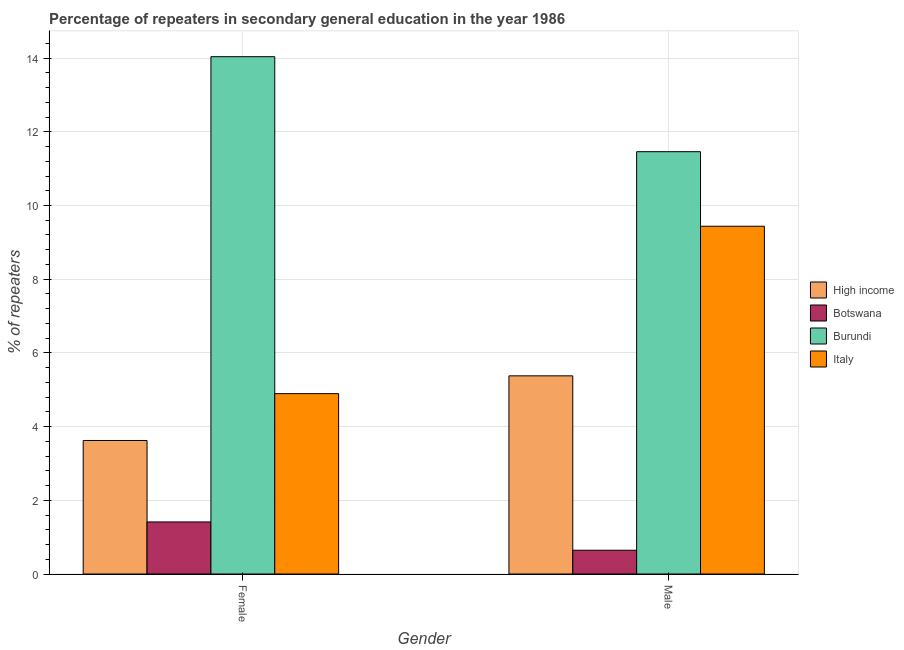Are the number of bars per tick equal to the number of legend labels?
Your response must be concise. Yes. Are the number of bars on each tick of the X-axis equal?
Provide a succinct answer. Yes. How many bars are there on the 2nd tick from the left?
Keep it short and to the point. 4. How many bars are there on the 1st tick from the right?
Offer a terse response. 4. What is the label of the 2nd group of bars from the left?
Your response must be concise. Male. What is the percentage of male repeaters in Italy?
Provide a short and direct response. 9.44. Across all countries, what is the maximum percentage of male repeaters?
Provide a succinct answer. 11.46. Across all countries, what is the minimum percentage of female repeaters?
Provide a succinct answer. 1.41. In which country was the percentage of male repeaters maximum?
Your answer should be very brief. Burundi. In which country was the percentage of male repeaters minimum?
Provide a short and direct response. Botswana. What is the total percentage of female repeaters in the graph?
Offer a terse response. 23.97. What is the difference between the percentage of male repeaters in Botswana and that in Burundi?
Your answer should be compact. -10.82. What is the difference between the percentage of male repeaters in High income and the percentage of female repeaters in Burundi?
Offer a very short reply. -8.66. What is the average percentage of male repeaters per country?
Your answer should be very brief. 6.73. What is the difference between the percentage of male repeaters and percentage of female repeaters in Botswana?
Make the answer very short. -0.77. What is the ratio of the percentage of female repeaters in Botswana to that in High income?
Your answer should be very brief. 0.39. Is the percentage of male repeaters in High income less than that in Burundi?
Provide a short and direct response. Yes. What does the 4th bar from the left in Female represents?
Your response must be concise. Italy. What does the 4th bar from the right in Male represents?
Give a very brief answer. High income. How many bars are there?
Ensure brevity in your answer.  8. Are all the bars in the graph horizontal?
Offer a very short reply. No. How many countries are there in the graph?
Keep it short and to the point. 4. Does the graph contain any zero values?
Give a very brief answer. No. How many legend labels are there?
Your answer should be very brief. 4. How are the legend labels stacked?
Your answer should be very brief. Vertical. What is the title of the graph?
Offer a terse response. Percentage of repeaters in secondary general education in the year 1986. Does "European Union" appear as one of the legend labels in the graph?
Offer a very short reply. No. What is the label or title of the Y-axis?
Ensure brevity in your answer.  % of repeaters. What is the % of repeaters of High income in Female?
Your answer should be very brief. 3.62. What is the % of repeaters of Botswana in Female?
Your answer should be very brief. 1.41. What is the % of repeaters of Burundi in Female?
Your answer should be very brief. 14.04. What is the % of repeaters of Italy in Female?
Provide a succinct answer. 4.89. What is the % of repeaters in High income in Male?
Your response must be concise. 5.38. What is the % of repeaters of Botswana in Male?
Offer a very short reply. 0.64. What is the % of repeaters of Burundi in Male?
Provide a short and direct response. 11.46. What is the % of repeaters in Italy in Male?
Give a very brief answer. 9.44. Across all Gender, what is the maximum % of repeaters in High income?
Ensure brevity in your answer.  5.38. Across all Gender, what is the maximum % of repeaters in Botswana?
Keep it short and to the point. 1.41. Across all Gender, what is the maximum % of repeaters in Burundi?
Your response must be concise. 14.04. Across all Gender, what is the maximum % of repeaters of Italy?
Provide a short and direct response. 9.44. Across all Gender, what is the minimum % of repeaters in High income?
Your answer should be very brief. 3.62. Across all Gender, what is the minimum % of repeaters of Botswana?
Your answer should be very brief. 0.64. Across all Gender, what is the minimum % of repeaters in Burundi?
Your answer should be very brief. 11.46. Across all Gender, what is the minimum % of repeaters in Italy?
Offer a terse response. 4.89. What is the total % of repeaters of High income in the graph?
Keep it short and to the point. 9. What is the total % of repeaters in Botswana in the graph?
Keep it short and to the point. 2.06. What is the total % of repeaters in Burundi in the graph?
Keep it short and to the point. 25.5. What is the total % of repeaters in Italy in the graph?
Give a very brief answer. 14.33. What is the difference between the % of repeaters of High income in Female and that in Male?
Offer a very short reply. -1.75. What is the difference between the % of repeaters in Botswana in Female and that in Male?
Make the answer very short. 0.77. What is the difference between the % of repeaters of Burundi in Female and that in Male?
Provide a succinct answer. 2.58. What is the difference between the % of repeaters of Italy in Female and that in Male?
Ensure brevity in your answer.  -4.54. What is the difference between the % of repeaters of High income in Female and the % of repeaters of Botswana in Male?
Offer a terse response. 2.98. What is the difference between the % of repeaters in High income in Female and the % of repeaters in Burundi in Male?
Provide a short and direct response. -7.84. What is the difference between the % of repeaters of High income in Female and the % of repeaters of Italy in Male?
Offer a very short reply. -5.81. What is the difference between the % of repeaters of Botswana in Female and the % of repeaters of Burundi in Male?
Your answer should be very brief. -10.05. What is the difference between the % of repeaters of Botswana in Female and the % of repeaters of Italy in Male?
Ensure brevity in your answer.  -8.02. What is the difference between the % of repeaters in Burundi in Female and the % of repeaters in Italy in Male?
Your answer should be compact. 4.6. What is the average % of repeaters of High income per Gender?
Offer a terse response. 4.5. What is the average % of repeaters of Botswana per Gender?
Make the answer very short. 1.03. What is the average % of repeaters in Burundi per Gender?
Ensure brevity in your answer.  12.75. What is the average % of repeaters in Italy per Gender?
Provide a succinct answer. 7.17. What is the difference between the % of repeaters in High income and % of repeaters in Botswana in Female?
Your answer should be compact. 2.21. What is the difference between the % of repeaters in High income and % of repeaters in Burundi in Female?
Ensure brevity in your answer.  -10.41. What is the difference between the % of repeaters of High income and % of repeaters of Italy in Female?
Ensure brevity in your answer.  -1.27. What is the difference between the % of repeaters in Botswana and % of repeaters in Burundi in Female?
Provide a succinct answer. -12.63. What is the difference between the % of repeaters in Botswana and % of repeaters in Italy in Female?
Offer a very short reply. -3.48. What is the difference between the % of repeaters in Burundi and % of repeaters in Italy in Female?
Your answer should be compact. 9.14. What is the difference between the % of repeaters of High income and % of repeaters of Botswana in Male?
Your answer should be compact. 4.73. What is the difference between the % of repeaters in High income and % of repeaters in Burundi in Male?
Offer a terse response. -6.08. What is the difference between the % of repeaters in High income and % of repeaters in Italy in Male?
Ensure brevity in your answer.  -4.06. What is the difference between the % of repeaters in Botswana and % of repeaters in Burundi in Male?
Your answer should be very brief. -10.81. What is the difference between the % of repeaters in Botswana and % of repeaters in Italy in Male?
Your response must be concise. -8.79. What is the difference between the % of repeaters in Burundi and % of repeaters in Italy in Male?
Offer a terse response. 2.02. What is the ratio of the % of repeaters of High income in Female to that in Male?
Your answer should be compact. 0.67. What is the ratio of the % of repeaters in Botswana in Female to that in Male?
Provide a succinct answer. 2.19. What is the ratio of the % of repeaters of Burundi in Female to that in Male?
Your answer should be compact. 1.23. What is the ratio of the % of repeaters in Italy in Female to that in Male?
Offer a very short reply. 0.52. What is the difference between the highest and the second highest % of repeaters in High income?
Provide a short and direct response. 1.75. What is the difference between the highest and the second highest % of repeaters of Botswana?
Make the answer very short. 0.77. What is the difference between the highest and the second highest % of repeaters in Burundi?
Your answer should be compact. 2.58. What is the difference between the highest and the second highest % of repeaters in Italy?
Make the answer very short. 4.54. What is the difference between the highest and the lowest % of repeaters of High income?
Ensure brevity in your answer.  1.75. What is the difference between the highest and the lowest % of repeaters of Botswana?
Ensure brevity in your answer.  0.77. What is the difference between the highest and the lowest % of repeaters in Burundi?
Your answer should be very brief. 2.58. What is the difference between the highest and the lowest % of repeaters in Italy?
Provide a short and direct response. 4.54. 